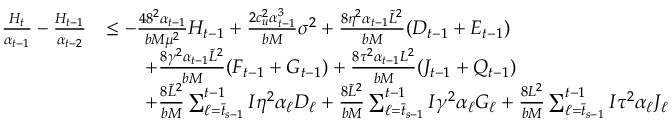Convert formula to latex. <formula><loc_0><loc_0><loc_500><loc_500>\begin{array} { r l } { \frac { H _ { t } } { \alpha _ { t - 1 } } - \frac { H _ { t - 1 } } { \alpha _ { t - 2 } } } & { \leq - \frac { 4 8 ^ { 2 } \alpha _ { t - 1 } } { b M \mu ^ { 2 } } H _ { t - 1 } + \frac { 2 c _ { u } ^ { 2 } \alpha _ { t - 1 } ^ { 3 } } { b M } \sigma ^ { 2 } + \frac { 8 \eta ^ { 2 } \alpha _ { t - 1 } \tilde { L } ^ { 2 } } { b M } ( D _ { t - 1 } + E _ { t - 1 } ) } \\ & { \quad + \frac { 8 \gamma ^ { 2 } \alpha _ { t - 1 } \tilde { L } ^ { 2 } } { b M } ( F _ { t - 1 } + G _ { t - 1 } ) + \frac { 8 \tau ^ { 2 } \alpha _ { t - 1 } L ^ { 2 } } { b M } ( J _ { t - 1 } + Q _ { t - 1 } ) } \\ & { \quad + \frac { 8 \tilde { L } ^ { 2 } } { b M } \sum _ { \ell = \bar { t } _ { s - 1 } } ^ { t - 1 } I \eta ^ { 2 } \alpha _ { \ell } D _ { \ell } + \frac { 8 \tilde { L } ^ { 2 } } { b M } \sum _ { \ell = \bar { t } _ { s - 1 } } ^ { t - 1 } I \gamma ^ { 2 } \alpha _ { \ell } G _ { \ell } + \frac { 8 L ^ { 2 } } { b M } \sum _ { \ell = \bar { t } _ { s - 1 } } ^ { t - 1 } I \tau ^ { 2 } \alpha _ { \ell } J _ { \ell } } \end{array}</formula> 